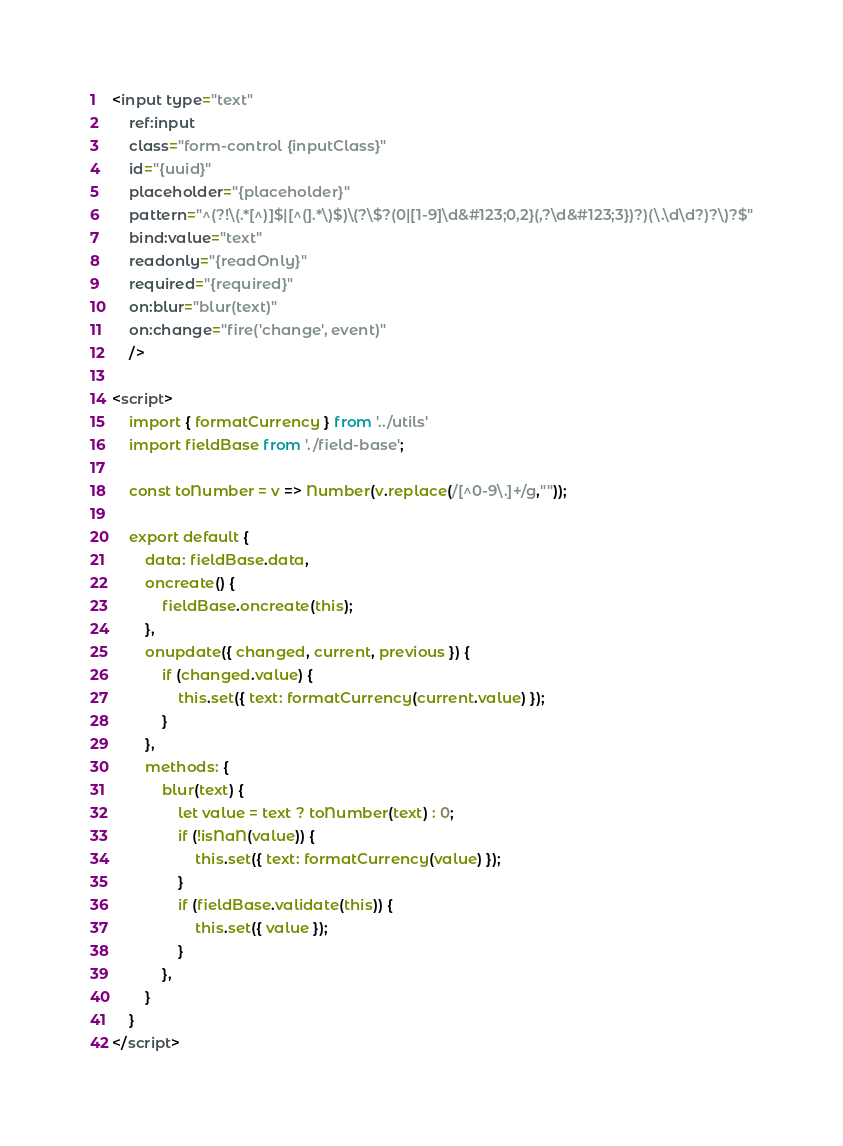Convert code to text. <code><loc_0><loc_0><loc_500><loc_500><_HTML_><input type="text"
    ref:input 
    class="form-control {inputClass}" 
    id="{uuid}" 
    placeholder="{placeholder}"
    pattern="^(?!\(.*[^)]$|[^(].*\)$)\(?\$?(0|[1-9]\d&#123;0,2}(,?\d&#123;3})?)(\.\d\d?)?\)?$"
    bind:value="text"
    readonly="{readOnly}"
    required="{required}" 
    on:blur="blur(text)"
    on:change="fire('change', event)"      
    />

<script>
    import { formatCurrency } from '../utils'
    import fieldBase from './field-base';

    const toNumber = v => Number(v.replace(/[^0-9\.]+/g,""));

    export default {
        data: fieldBase.data,
        oncreate() {
            fieldBase.oncreate(this);
        },
        onupdate({ changed, current, previous }) {
            if (changed.value) {
                this.set({ text: formatCurrency(current.value) });
            }
        },
        methods: {
            blur(text) {
                let value = text ? toNumber(text) : 0;
                if (!isNaN(value)) {
                    this.set({ text: formatCurrency(value) });
                }
                if (fieldBase.validate(this)) {                    
                    this.set({ value });
                }              
            },
        }
    }
</script>
</code> 